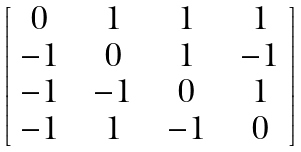<formula> <loc_0><loc_0><loc_500><loc_500>\begin{bmatrix} 0 & \ 1 \ & \ 1 \ & \ 1 \ \\ \ - 1 \ & 0 & \ 1 \ & \ - 1 \ \\ \ - 1 \ & \ - 1 \ & 0 & \ 1 \ \\ \ - 1 \ & \ 1 \ & \ - 1 \ & 0 \\ \end{bmatrix}</formula> 